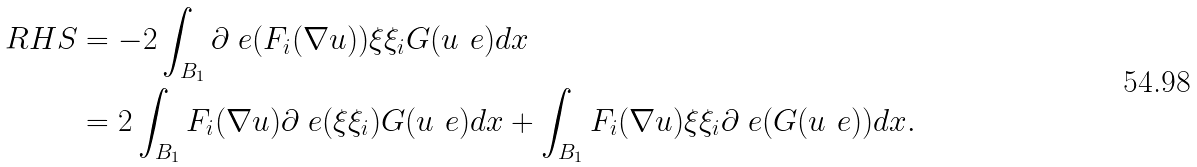Convert formula to latex. <formula><loc_0><loc_0><loc_500><loc_500>R H S & = - 2 \int _ { B _ { 1 } } \partial _ { \ } e ( F _ { i } ( \nabla u ) ) \xi \xi _ { i } G ( u _ { \ } e ) d x \\ & = 2 \int _ { B _ { 1 } } F _ { i } ( \nabla u ) \partial _ { \ } e ( \xi \xi _ { i } ) G ( u _ { \ } e ) d x + \int _ { B _ { 1 } } F _ { i } ( \nabla u ) \xi \xi _ { i } \partial _ { \ } e ( G ( u _ { \ } e ) ) d x .</formula> 